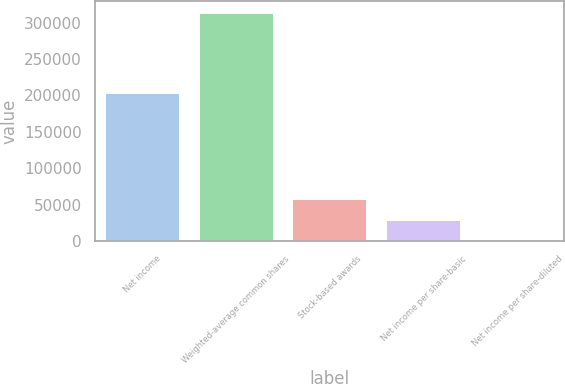Convert chart to OTSL. <chart><loc_0><loc_0><loc_500><loc_500><bar_chart><fcel>Net income<fcel>Weighted-average common shares<fcel>Stock-based awards<fcel>Net income per share-basic<fcel>Net income per share-diluted<nl><fcel>203086<fcel>313628<fcel>58251.8<fcel>29126.2<fcel>0.7<nl></chart> 